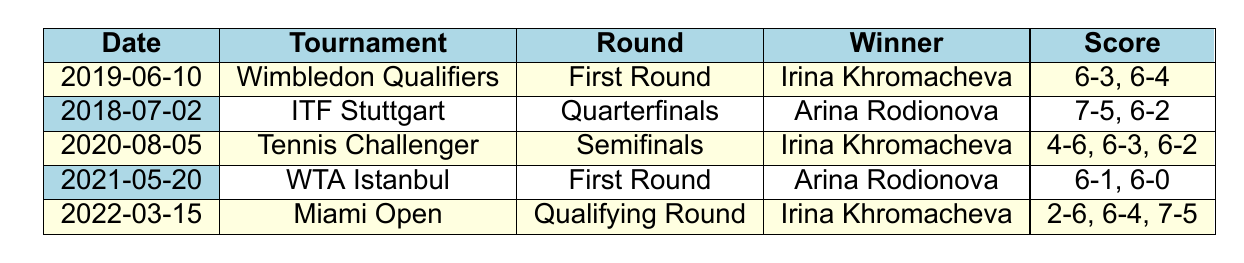What was the score in the match on June 10, 2019? The table shows that the match on June 10, 2019, had a score of 6-3, 6-4.
Answer: 6-3, 6-4 Which player won the 2020 match at the Tennis Challenger? According to the table, Irina Khromacheva won the match at the Tennis Challenger in 2020.
Answer: Irina Khromacheva How many matches did Irina Khromacheva win in the data provided? By reviewing the table, Irina Khromacheva won 3 matches (on June 10, 2019; August 5, 2020; and March 15, 2022).
Answer: 3 Did Arina Rodionova win any matches in 2021? The table indicates that Arina Rodionova won a match on May 20, 2021.
Answer: Yes What is the difference in match scores between Irina Khromacheva's first match and her latest match? Irina Khromacheva's first match score was 6-3, 6-4, and her latest match score was 2-6, 6-4, 7-5. To find the difference, analyze both scores: the first match had 2 sets, while the latest had 3 sets won with scores indicating a comeback after losing the first set. The scores show a 1 set win difference in upcoming matches favoring her resilience.
Answer: 1 set win difference What was the round of the earliest match recorded for Arina Rodionova? The earliest match listed for Arina Rodionova took place on July 2, 2018, in the Quarterfinals at the ITF Stuttgart.
Answer: Quarterfinals In which tournament did Irina Khromacheva have her most recent victory? According to the table, Irina Khromacheva's most recent victory occurred at the Miami Open on March 15, 2022.
Answer: Miami Open How many times did Arina Rodionova win in the first round? By checking the matches, Arina Rodionova won once in the first round at WTA Istanbul on May 20, 2021.
Answer: 1 time Which player had the most straightforward victory based on set scores? Based on the scores, Arina Rodionova's match on May 20, 2021, with a score of 6-1, 6-0 reflects a more dominant performance with no games lost in the second set compared to other matches.
Answer: Arina Rodionova 